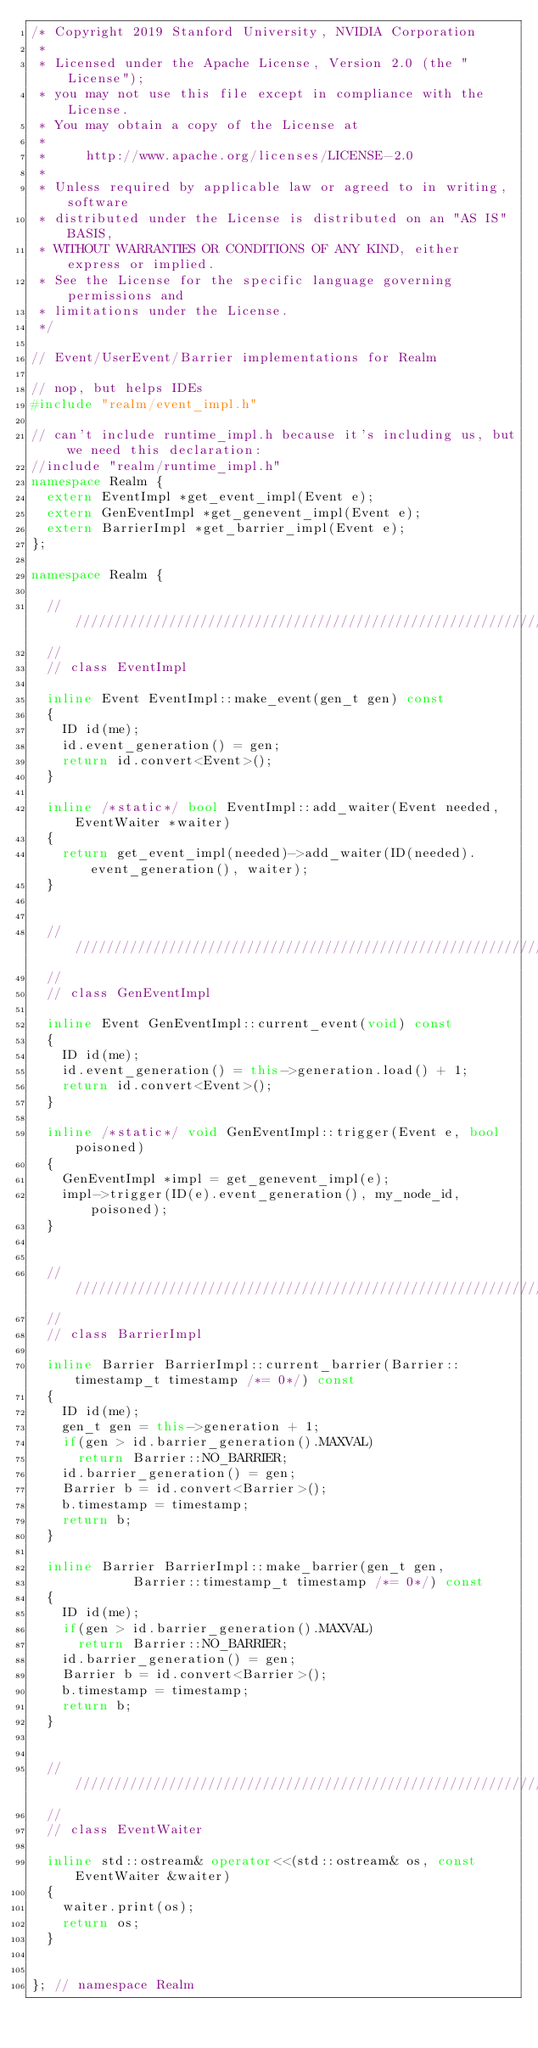<code> <loc_0><loc_0><loc_500><loc_500><_C++_>/* Copyright 2019 Stanford University, NVIDIA Corporation
 *
 * Licensed under the Apache License, Version 2.0 (the "License");
 * you may not use this file except in compliance with the License.
 * You may obtain a copy of the License at
 *
 *     http://www.apache.org/licenses/LICENSE-2.0
 *
 * Unless required by applicable law or agreed to in writing, software
 * distributed under the License is distributed on an "AS IS" BASIS,
 * WITHOUT WARRANTIES OR CONDITIONS OF ANY KIND, either express or implied.
 * See the License for the specific language governing permissions and
 * limitations under the License.
 */

// Event/UserEvent/Barrier implementations for Realm

// nop, but helps IDEs
#include "realm/event_impl.h"

// can't include runtime_impl.h because it's including us, but we need this declaration:
//include "realm/runtime_impl.h"
namespace Realm { 
  extern EventImpl *get_event_impl(Event e);
  extern GenEventImpl *get_genevent_impl(Event e);
  extern BarrierImpl *get_barrier_impl(Event e);
};

namespace Realm {

  ////////////////////////////////////////////////////////////////////////
  //
  // class EventImpl

  inline Event EventImpl::make_event(gen_t gen) const
  {
    ID id(me);
    id.event_generation() = gen;
    return id.convert<Event>();
  }

  inline /*static*/ bool EventImpl::add_waiter(Event needed, EventWaiter *waiter)
  {
    return get_event_impl(needed)->add_waiter(ID(needed).event_generation(), waiter);
  }


  ////////////////////////////////////////////////////////////////////////
  //
  // class GenEventImpl

  inline Event GenEventImpl::current_event(void) const
  {
    ID id(me);
    id.event_generation() = this->generation.load() + 1;
    return id.convert<Event>();
  }

  inline /*static*/ void GenEventImpl::trigger(Event e, bool poisoned)
  {
    GenEventImpl *impl = get_genevent_impl(e);
    impl->trigger(ID(e).event_generation(), my_node_id, poisoned);
  }


  ////////////////////////////////////////////////////////////////////////
  //
  // class BarrierImpl

  inline Barrier BarrierImpl::current_barrier(Barrier::timestamp_t timestamp /*= 0*/) const
  {
    ID id(me);
    gen_t gen = this->generation + 1;
    if(gen > id.barrier_generation().MAXVAL)
      return Barrier::NO_BARRIER;
    id.barrier_generation() = gen;
    Barrier b = id.convert<Barrier>();
    b.timestamp = timestamp;
    return b;
  }

  inline Barrier BarrierImpl::make_barrier(gen_t gen,
					   Barrier::timestamp_t timestamp /*= 0*/) const
  {
    ID id(me);
    if(gen > id.barrier_generation().MAXVAL)
      return Barrier::NO_BARRIER;
    id.barrier_generation() = gen;
    Barrier b = id.convert<Barrier>();
    b.timestamp = timestamp;
    return b;
  }


  ////////////////////////////////////////////////////////////////////////
  //
  // class EventWaiter

  inline std::ostream& operator<<(std::ostream& os, const EventWaiter &waiter)
  {
    waiter.print(os);
    return os;
  }


}; // namespace Realm

</code> 